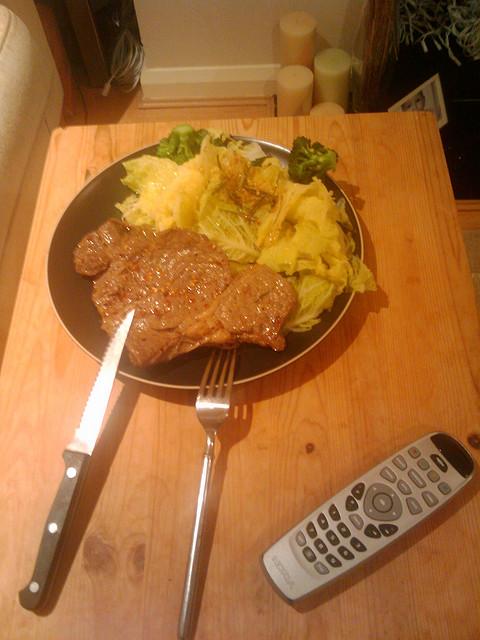What cut of meat is that?
Answer briefly. Steak. What is on the floor?
Short answer required. Candles. What might the eater of this meal be planning to do while eating?
Keep it brief. Watch tv. 